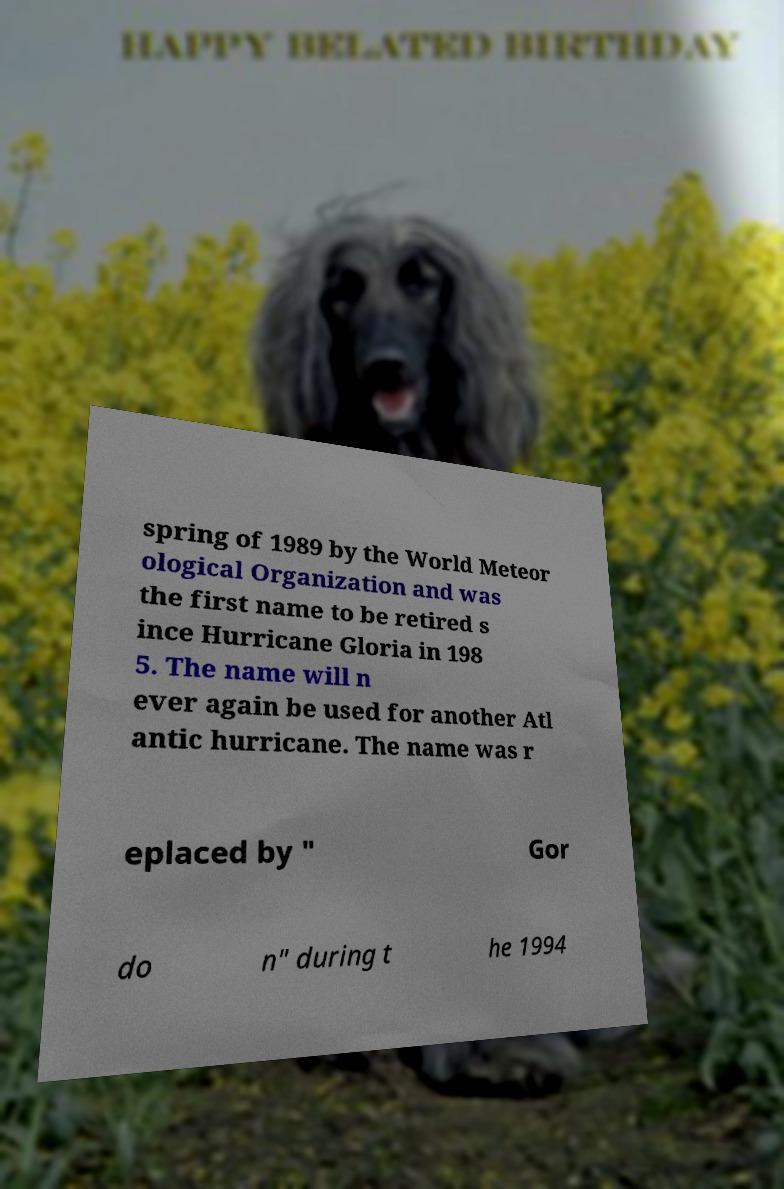I need the written content from this picture converted into text. Can you do that? spring of 1989 by the World Meteor ological Organization and was the first name to be retired s ince Hurricane Gloria in 198 5. The name will n ever again be used for another Atl antic hurricane. The name was r eplaced by " Gor do n" during t he 1994 